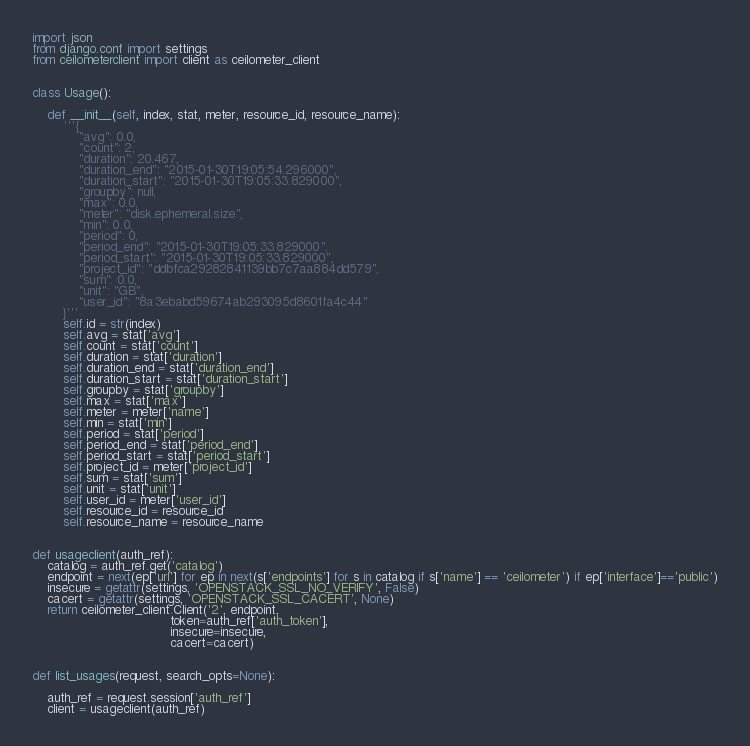<code> <loc_0><loc_0><loc_500><loc_500><_Python_>
import json
from django.conf import settings
from ceilometerclient import client as ceilometer_client


class Usage():
    
    def __init__(self, index, stat, meter, resource_id, resource_name):
        '''{
            "avg": 0.0,
            "count": 2,
            "duration": 20.467,
            "duration_end": "2015-01-30T19:05:54.296000",
            "duration_start": "2015-01-30T19:05:33.829000",
            "groupby": null,
            "max": 0.0,
            "meter": "disk.ephemeral.size",
            "min": 0.0,
            "period": 0,
            "period_end": "2015-01-30T19:05:33.829000",
            "period_start": "2015-01-30T19:05:33.829000",
            "project_id": "ddbfca29282841139bb7c7aa884dd579",
            "sum": 0.0,
            "unit": "GB",
            "user_id": "8a3ebabd59674ab293095d8601fa4c44"
        }'''
        self.id = str(index)
        self.avg = stat['avg']
        self.count = stat['count']
        self.duration = stat['duration']
        self.duration_end = stat['duration_end']
        self.duration_start = stat['duration_start']
        self.groupby = stat['groupby']
        self.max = stat['max']
        self.meter = meter['name']
        self.min = stat['min']
        self.period = stat['period']
        self.period_end = stat['period_end']
        self.period_start = stat['period_start']
        self.project_id = meter['project_id']
        self.sum = stat['sum']
        self.unit = stat['unit']
        self.user_id = meter['user_id']
        self.resource_id = resource_id
        self.resource_name = resource_name


def usageclient(auth_ref):
    catalog = auth_ref.get('catalog')
    endpoint = next(ep['url'] for ep in next(s['endpoints'] for s in catalog if s['name'] == 'ceilometer') if ep['interface']=='public')
    insecure = getattr(settings, 'OPENSTACK_SSL_NO_VERIFY', False)
    cacert = getattr(settings, 'OPENSTACK_SSL_CACERT', None)
    return ceilometer_client.Client('2', endpoint,
                                    token=auth_ref['auth_token'],
                                    insecure=insecure,
                                    cacert=cacert)

        
def list_usages(request, search_opts=None):
    
    auth_ref = request.session['auth_ref']
    client = usageclient(auth_ref)
</code> 